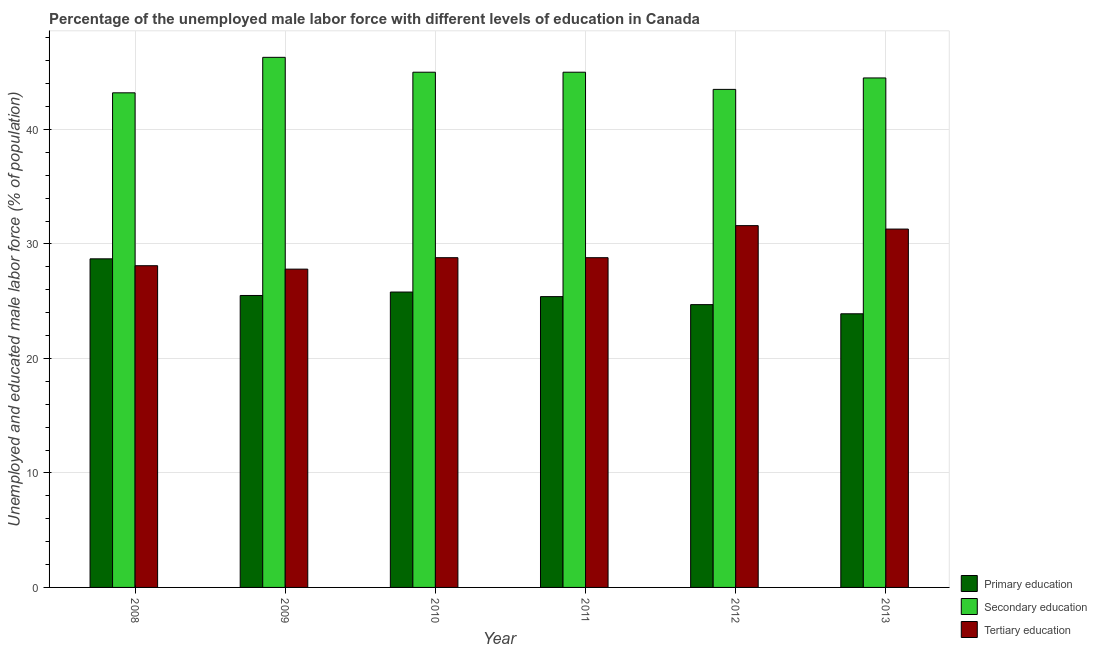Are the number of bars on each tick of the X-axis equal?
Make the answer very short. Yes. How many bars are there on the 3rd tick from the right?
Make the answer very short. 3. In how many cases, is the number of bars for a given year not equal to the number of legend labels?
Offer a very short reply. 0. What is the percentage of male labor force who received secondary education in 2008?
Ensure brevity in your answer.  43.2. Across all years, what is the maximum percentage of male labor force who received tertiary education?
Your answer should be very brief. 31.6. Across all years, what is the minimum percentage of male labor force who received tertiary education?
Offer a terse response. 27.8. In which year was the percentage of male labor force who received primary education maximum?
Your answer should be very brief. 2008. In which year was the percentage of male labor force who received secondary education minimum?
Keep it short and to the point. 2008. What is the total percentage of male labor force who received primary education in the graph?
Your answer should be very brief. 154. What is the difference between the percentage of male labor force who received primary education in 2013 and the percentage of male labor force who received tertiary education in 2012?
Offer a terse response. -0.8. What is the average percentage of male labor force who received secondary education per year?
Your response must be concise. 44.58. In the year 2008, what is the difference between the percentage of male labor force who received tertiary education and percentage of male labor force who received secondary education?
Your answer should be compact. 0. In how many years, is the percentage of male labor force who received secondary education greater than 34 %?
Make the answer very short. 6. What is the ratio of the percentage of male labor force who received tertiary education in 2011 to that in 2013?
Offer a terse response. 0.92. Is the percentage of male labor force who received primary education in 2008 less than that in 2012?
Offer a terse response. No. What is the difference between the highest and the second highest percentage of male labor force who received tertiary education?
Keep it short and to the point. 0.3. What is the difference between the highest and the lowest percentage of male labor force who received primary education?
Make the answer very short. 4.8. What does the 2nd bar from the left in 2013 represents?
Give a very brief answer. Secondary education. What does the 2nd bar from the right in 2008 represents?
Your response must be concise. Secondary education. Is it the case that in every year, the sum of the percentage of male labor force who received primary education and percentage of male labor force who received secondary education is greater than the percentage of male labor force who received tertiary education?
Make the answer very short. Yes. How many bars are there?
Ensure brevity in your answer.  18. Are all the bars in the graph horizontal?
Your answer should be compact. No. How many years are there in the graph?
Make the answer very short. 6. Are the values on the major ticks of Y-axis written in scientific E-notation?
Provide a succinct answer. No. Does the graph contain any zero values?
Ensure brevity in your answer.  No. Where does the legend appear in the graph?
Your answer should be compact. Bottom right. How many legend labels are there?
Your response must be concise. 3. What is the title of the graph?
Offer a very short reply. Percentage of the unemployed male labor force with different levels of education in Canada. Does "Tertiary" appear as one of the legend labels in the graph?
Your response must be concise. No. What is the label or title of the Y-axis?
Provide a succinct answer. Unemployed and educated male labor force (% of population). What is the Unemployed and educated male labor force (% of population) in Primary education in 2008?
Your answer should be compact. 28.7. What is the Unemployed and educated male labor force (% of population) in Secondary education in 2008?
Your answer should be compact. 43.2. What is the Unemployed and educated male labor force (% of population) in Tertiary education in 2008?
Provide a succinct answer. 28.1. What is the Unemployed and educated male labor force (% of population) of Secondary education in 2009?
Give a very brief answer. 46.3. What is the Unemployed and educated male labor force (% of population) in Tertiary education in 2009?
Make the answer very short. 27.8. What is the Unemployed and educated male labor force (% of population) of Primary education in 2010?
Your response must be concise. 25.8. What is the Unemployed and educated male labor force (% of population) of Secondary education in 2010?
Offer a very short reply. 45. What is the Unemployed and educated male labor force (% of population) of Tertiary education in 2010?
Your answer should be very brief. 28.8. What is the Unemployed and educated male labor force (% of population) of Primary education in 2011?
Your answer should be very brief. 25.4. What is the Unemployed and educated male labor force (% of population) in Tertiary education in 2011?
Make the answer very short. 28.8. What is the Unemployed and educated male labor force (% of population) of Primary education in 2012?
Offer a terse response. 24.7. What is the Unemployed and educated male labor force (% of population) of Secondary education in 2012?
Keep it short and to the point. 43.5. What is the Unemployed and educated male labor force (% of population) of Tertiary education in 2012?
Your response must be concise. 31.6. What is the Unemployed and educated male labor force (% of population) of Primary education in 2013?
Keep it short and to the point. 23.9. What is the Unemployed and educated male labor force (% of population) in Secondary education in 2013?
Offer a very short reply. 44.5. What is the Unemployed and educated male labor force (% of population) of Tertiary education in 2013?
Provide a succinct answer. 31.3. Across all years, what is the maximum Unemployed and educated male labor force (% of population) in Primary education?
Give a very brief answer. 28.7. Across all years, what is the maximum Unemployed and educated male labor force (% of population) in Secondary education?
Keep it short and to the point. 46.3. Across all years, what is the maximum Unemployed and educated male labor force (% of population) in Tertiary education?
Ensure brevity in your answer.  31.6. Across all years, what is the minimum Unemployed and educated male labor force (% of population) of Primary education?
Give a very brief answer. 23.9. Across all years, what is the minimum Unemployed and educated male labor force (% of population) of Secondary education?
Make the answer very short. 43.2. Across all years, what is the minimum Unemployed and educated male labor force (% of population) in Tertiary education?
Provide a succinct answer. 27.8. What is the total Unemployed and educated male labor force (% of population) of Primary education in the graph?
Ensure brevity in your answer.  154. What is the total Unemployed and educated male labor force (% of population) of Secondary education in the graph?
Provide a short and direct response. 267.5. What is the total Unemployed and educated male labor force (% of population) in Tertiary education in the graph?
Keep it short and to the point. 176.4. What is the difference between the Unemployed and educated male labor force (% of population) in Primary education in 2008 and that in 2009?
Provide a short and direct response. 3.2. What is the difference between the Unemployed and educated male labor force (% of population) in Secondary education in 2008 and that in 2009?
Your response must be concise. -3.1. What is the difference between the Unemployed and educated male labor force (% of population) of Tertiary education in 2008 and that in 2009?
Offer a very short reply. 0.3. What is the difference between the Unemployed and educated male labor force (% of population) in Tertiary education in 2008 and that in 2010?
Keep it short and to the point. -0.7. What is the difference between the Unemployed and educated male labor force (% of population) in Primary education in 2008 and that in 2011?
Your response must be concise. 3.3. What is the difference between the Unemployed and educated male labor force (% of population) of Secondary education in 2008 and that in 2012?
Make the answer very short. -0.3. What is the difference between the Unemployed and educated male labor force (% of population) of Primary education in 2008 and that in 2013?
Offer a terse response. 4.8. What is the difference between the Unemployed and educated male labor force (% of population) in Primary education in 2009 and that in 2010?
Keep it short and to the point. -0.3. What is the difference between the Unemployed and educated male labor force (% of population) in Secondary education in 2009 and that in 2010?
Offer a terse response. 1.3. What is the difference between the Unemployed and educated male labor force (% of population) in Tertiary education in 2009 and that in 2010?
Provide a succinct answer. -1. What is the difference between the Unemployed and educated male labor force (% of population) in Tertiary education in 2009 and that in 2011?
Give a very brief answer. -1. What is the difference between the Unemployed and educated male labor force (% of population) in Primary education in 2009 and that in 2012?
Provide a succinct answer. 0.8. What is the difference between the Unemployed and educated male labor force (% of population) of Secondary education in 2009 and that in 2013?
Provide a short and direct response. 1.8. What is the difference between the Unemployed and educated male labor force (% of population) in Tertiary education in 2009 and that in 2013?
Provide a short and direct response. -3.5. What is the difference between the Unemployed and educated male labor force (% of population) of Tertiary education in 2010 and that in 2011?
Give a very brief answer. 0. What is the difference between the Unemployed and educated male labor force (% of population) of Primary education in 2010 and that in 2012?
Offer a very short reply. 1.1. What is the difference between the Unemployed and educated male labor force (% of population) in Secondary education in 2010 and that in 2012?
Make the answer very short. 1.5. What is the difference between the Unemployed and educated male labor force (% of population) of Secondary education in 2010 and that in 2013?
Give a very brief answer. 0.5. What is the difference between the Unemployed and educated male labor force (% of population) of Tertiary education in 2010 and that in 2013?
Give a very brief answer. -2.5. What is the difference between the Unemployed and educated male labor force (% of population) in Primary education in 2011 and that in 2012?
Offer a terse response. 0.7. What is the difference between the Unemployed and educated male labor force (% of population) of Secondary education in 2011 and that in 2012?
Provide a short and direct response. 1.5. What is the difference between the Unemployed and educated male labor force (% of population) of Tertiary education in 2011 and that in 2012?
Make the answer very short. -2.8. What is the difference between the Unemployed and educated male labor force (% of population) of Secondary education in 2011 and that in 2013?
Keep it short and to the point. 0.5. What is the difference between the Unemployed and educated male labor force (% of population) in Secondary education in 2012 and that in 2013?
Ensure brevity in your answer.  -1. What is the difference between the Unemployed and educated male labor force (% of population) of Primary education in 2008 and the Unemployed and educated male labor force (% of population) of Secondary education in 2009?
Make the answer very short. -17.6. What is the difference between the Unemployed and educated male labor force (% of population) in Secondary education in 2008 and the Unemployed and educated male labor force (% of population) in Tertiary education in 2009?
Ensure brevity in your answer.  15.4. What is the difference between the Unemployed and educated male labor force (% of population) in Primary education in 2008 and the Unemployed and educated male labor force (% of population) in Secondary education in 2010?
Your response must be concise. -16.3. What is the difference between the Unemployed and educated male labor force (% of population) of Primary education in 2008 and the Unemployed and educated male labor force (% of population) of Tertiary education in 2010?
Make the answer very short. -0.1. What is the difference between the Unemployed and educated male labor force (% of population) in Primary education in 2008 and the Unemployed and educated male labor force (% of population) in Secondary education in 2011?
Keep it short and to the point. -16.3. What is the difference between the Unemployed and educated male labor force (% of population) of Primary education in 2008 and the Unemployed and educated male labor force (% of population) of Tertiary education in 2011?
Ensure brevity in your answer.  -0.1. What is the difference between the Unemployed and educated male labor force (% of population) of Secondary education in 2008 and the Unemployed and educated male labor force (% of population) of Tertiary education in 2011?
Ensure brevity in your answer.  14.4. What is the difference between the Unemployed and educated male labor force (% of population) in Primary education in 2008 and the Unemployed and educated male labor force (% of population) in Secondary education in 2012?
Your answer should be compact. -14.8. What is the difference between the Unemployed and educated male labor force (% of population) in Primary education in 2008 and the Unemployed and educated male labor force (% of population) in Secondary education in 2013?
Ensure brevity in your answer.  -15.8. What is the difference between the Unemployed and educated male labor force (% of population) of Primary education in 2008 and the Unemployed and educated male labor force (% of population) of Tertiary education in 2013?
Your answer should be compact. -2.6. What is the difference between the Unemployed and educated male labor force (% of population) in Secondary education in 2008 and the Unemployed and educated male labor force (% of population) in Tertiary education in 2013?
Your answer should be very brief. 11.9. What is the difference between the Unemployed and educated male labor force (% of population) of Primary education in 2009 and the Unemployed and educated male labor force (% of population) of Secondary education in 2010?
Offer a very short reply. -19.5. What is the difference between the Unemployed and educated male labor force (% of population) of Primary education in 2009 and the Unemployed and educated male labor force (% of population) of Tertiary education in 2010?
Your answer should be very brief. -3.3. What is the difference between the Unemployed and educated male labor force (% of population) in Secondary education in 2009 and the Unemployed and educated male labor force (% of population) in Tertiary education in 2010?
Your answer should be compact. 17.5. What is the difference between the Unemployed and educated male labor force (% of population) in Primary education in 2009 and the Unemployed and educated male labor force (% of population) in Secondary education in 2011?
Your answer should be compact. -19.5. What is the difference between the Unemployed and educated male labor force (% of population) in Primary education in 2009 and the Unemployed and educated male labor force (% of population) in Tertiary education in 2012?
Provide a succinct answer. -6.1. What is the difference between the Unemployed and educated male labor force (% of population) of Secondary education in 2009 and the Unemployed and educated male labor force (% of population) of Tertiary education in 2012?
Give a very brief answer. 14.7. What is the difference between the Unemployed and educated male labor force (% of population) in Primary education in 2009 and the Unemployed and educated male labor force (% of population) in Secondary education in 2013?
Provide a short and direct response. -19. What is the difference between the Unemployed and educated male labor force (% of population) in Primary education in 2010 and the Unemployed and educated male labor force (% of population) in Secondary education in 2011?
Provide a short and direct response. -19.2. What is the difference between the Unemployed and educated male labor force (% of population) in Secondary education in 2010 and the Unemployed and educated male labor force (% of population) in Tertiary education in 2011?
Your answer should be very brief. 16.2. What is the difference between the Unemployed and educated male labor force (% of population) in Primary education in 2010 and the Unemployed and educated male labor force (% of population) in Secondary education in 2012?
Make the answer very short. -17.7. What is the difference between the Unemployed and educated male labor force (% of population) in Primary education in 2010 and the Unemployed and educated male labor force (% of population) in Tertiary education in 2012?
Offer a very short reply. -5.8. What is the difference between the Unemployed and educated male labor force (% of population) in Secondary education in 2010 and the Unemployed and educated male labor force (% of population) in Tertiary education in 2012?
Your answer should be compact. 13.4. What is the difference between the Unemployed and educated male labor force (% of population) of Primary education in 2010 and the Unemployed and educated male labor force (% of population) of Secondary education in 2013?
Your answer should be compact. -18.7. What is the difference between the Unemployed and educated male labor force (% of population) in Secondary education in 2010 and the Unemployed and educated male labor force (% of population) in Tertiary education in 2013?
Give a very brief answer. 13.7. What is the difference between the Unemployed and educated male labor force (% of population) of Primary education in 2011 and the Unemployed and educated male labor force (% of population) of Secondary education in 2012?
Provide a succinct answer. -18.1. What is the difference between the Unemployed and educated male labor force (% of population) of Primary education in 2011 and the Unemployed and educated male labor force (% of population) of Secondary education in 2013?
Offer a terse response. -19.1. What is the difference between the Unemployed and educated male labor force (% of population) of Primary education in 2012 and the Unemployed and educated male labor force (% of population) of Secondary education in 2013?
Your answer should be very brief. -19.8. What is the average Unemployed and educated male labor force (% of population) of Primary education per year?
Your response must be concise. 25.67. What is the average Unemployed and educated male labor force (% of population) of Secondary education per year?
Provide a short and direct response. 44.58. What is the average Unemployed and educated male labor force (% of population) in Tertiary education per year?
Make the answer very short. 29.4. In the year 2008, what is the difference between the Unemployed and educated male labor force (% of population) in Primary education and Unemployed and educated male labor force (% of population) in Tertiary education?
Provide a succinct answer. 0.6. In the year 2009, what is the difference between the Unemployed and educated male labor force (% of population) in Primary education and Unemployed and educated male labor force (% of population) in Secondary education?
Your response must be concise. -20.8. In the year 2009, what is the difference between the Unemployed and educated male labor force (% of population) of Secondary education and Unemployed and educated male labor force (% of population) of Tertiary education?
Ensure brevity in your answer.  18.5. In the year 2010, what is the difference between the Unemployed and educated male labor force (% of population) of Primary education and Unemployed and educated male labor force (% of population) of Secondary education?
Make the answer very short. -19.2. In the year 2011, what is the difference between the Unemployed and educated male labor force (% of population) in Primary education and Unemployed and educated male labor force (% of population) in Secondary education?
Provide a succinct answer. -19.6. In the year 2011, what is the difference between the Unemployed and educated male labor force (% of population) of Secondary education and Unemployed and educated male labor force (% of population) of Tertiary education?
Your response must be concise. 16.2. In the year 2012, what is the difference between the Unemployed and educated male labor force (% of population) in Primary education and Unemployed and educated male labor force (% of population) in Secondary education?
Provide a short and direct response. -18.8. In the year 2012, what is the difference between the Unemployed and educated male labor force (% of population) of Primary education and Unemployed and educated male labor force (% of population) of Tertiary education?
Ensure brevity in your answer.  -6.9. In the year 2013, what is the difference between the Unemployed and educated male labor force (% of population) in Primary education and Unemployed and educated male labor force (% of population) in Secondary education?
Your answer should be compact. -20.6. In the year 2013, what is the difference between the Unemployed and educated male labor force (% of population) of Primary education and Unemployed and educated male labor force (% of population) of Tertiary education?
Provide a short and direct response. -7.4. In the year 2013, what is the difference between the Unemployed and educated male labor force (% of population) in Secondary education and Unemployed and educated male labor force (% of population) in Tertiary education?
Offer a very short reply. 13.2. What is the ratio of the Unemployed and educated male labor force (% of population) of Primary education in 2008 to that in 2009?
Provide a short and direct response. 1.13. What is the ratio of the Unemployed and educated male labor force (% of population) in Secondary education in 2008 to that in 2009?
Make the answer very short. 0.93. What is the ratio of the Unemployed and educated male labor force (% of population) in Tertiary education in 2008 to that in 2009?
Your answer should be compact. 1.01. What is the ratio of the Unemployed and educated male labor force (% of population) of Primary education in 2008 to that in 2010?
Ensure brevity in your answer.  1.11. What is the ratio of the Unemployed and educated male labor force (% of population) in Secondary education in 2008 to that in 2010?
Keep it short and to the point. 0.96. What is the ratio of the Unemployed and educated male labor force (% of population) of Tertiary education in 2008 to that in 2010?
Keep it short and to the point. 0.98. What is the ratio of the Unemployed and educated male labor force (% of population) in Primary education in 2008 to that in 2011?
Provide a short and direct response. 1.13. What is the ratio of the Unemployed and educated male labor force (% of population) of Tertiary education in 2008 to that in 2011?
Provide a succinct answer. 0.98. What is the ratio of the Unemployed and educated male labor force (% of population) in Primary education in 2008 to that in 2012?
Offer a very short reply. 1.16. What is the ratio of the Unemployed and educated male labor force (% of population) of Tertiary education in 2008 to that in 2012?
Give a very brief answer. 0.89. What is the ratio of the Unemployed and educated male labor force (% of population) of Primary education in 2008 to that in 2013?
Offer a very short reply. 1.2. What is the ratio of the Unemployed and educated male labor force (% of population) of Secondary education in 2008 to that in 2013?
Provide a succinct answer. 0.97. What is the ratio of the Unemployed and educated male labor force (% of population) in Tertiary education in 2008 to that in 2013?
Provide a succinct answer. 0.9. What is the ratio of the Unemployed and educated male labor force (% of population) of Primary education in 2009 to that in 2010?
Your answer should be very brief. 0.99. What is the ratio of the Unemployed and educated male labor force (% of population) of Secondary education in 2009 to that in 2010?
Provide a short and direct response. 1.03. What is the ratio of the Unemployed and educated male labor force (% of population) of Tertiary education in 2009 to that in 2010?
Keep it short and to the point. 0.97. What is the ratio of the Unemployed and educated male labor force (% of population) of Primary education in 2009 to that in 2011?
Your answer should be compact. 1. What is the ratio of the Unemployed and educated male labor force (% of population) in Secondary education in 2009 to that in 2011?
Your answer should be very brief. 1.03. What is the ratio of the Unemployed and educated male labor force (% of population) of Tertiary education in 2009 to that in 2011?
Provide a short and direct response. 0.97. What is the ratio of the Unemployed and educated male labor force (% of population) in Primary education in 2009 to that in 2012?
Offer a very short reply. 1.03. What is the ratio of the Unemployed and educated male labor force (% of population) in Secondary education in 2009 to that in 2012?
Make the answer very short. 1.06. What is the ratio of the Unemployed and educated male labor force (% of population) in Tertiary education in 2009 to that in 2012?
Provide a succinct answer. 0.88. What is the ratio of the Unemployed and educated male labor force (% of population) in Primary education in 2009 to that in 2013?
Provide a succinct answer. 1.07. What is the ratio of the Unemployed and educated male labor force (% of population) of Secondary education in 2009 to that in 2013?
Provide a succinct answer. 1.04. What is the ratio of the Unemployed and educated male labor force (% of population) of Tertiary education in 2009 to that in 2013?
Offer a very short reply. 0.89. What is the ratio of the Unemployed and educated male labor force (% of population) of Primary education in 2010 to that in 2011?
Your response must be concise. 1.02. What is the ratio of the Unemployed and educated male labor force (% of population) of Secondary education in 2010 to that in 2011?
Offer a terse response. 1. What is the ratio of the Unemployed and educated male labor force (% of population) in Tertiary education in 2010 to that in 2011?
Provide a short and direct response. 1. What is the ratio of the Unemployed and educated male labor force (% of population) in Primary education in 2010 to that in 2012?
Offer a very short reply. 1.04. What is the ratio of the Unemployed and educated male labor force (% of population) in Secondary education in 2010 to that in 2012?
Your response must be concise. 1.03. What is the ratio of the Unemployed and educated male labor force (% of population) in Tertiary education in 2010 to that in 2012?
Provide a succinct answer. 0.91. What is the ratio of the Unemployed and educated male labor force (% of population) of Primary education in 2010 to that in 2013?
Provide a succinct answer. 1.08. What is the ratio of the Unemployed and educated male labor force (% of population) in Secondary education in 2010 to that in 2013?
Provide a short and direct response. 1.01. What is the ratio of the Unemployed and educated male labor force (% of population) of Tertiary education in 2010 to that in 2013?
Provide a short and direct response. 0.92. What is the ratio of the Unemployed and educated male labor force (% of population) in Primary education in 2011 to that in 2012?
Keep it short and to the point. 1.03. What is the ratio of the Unemployed and educated male labor force (% of population) in Secondary education in 2011 to that in 2012?
Keep it short and to the point. 1.03. What is the ratio of the Unemployed and educated male labor force (% of population) in Tertiary education in 2011 to that in 2012?
Provide a succinct answer. 0.91. What is the ratio of the Unemployed and educated male labor force (% of population) in Primary education in 2011 to that in 2013?
Provide a succinct answer. 1.06. What is the ratio of the Unemployed and educated male labor force (% of population) of Secondary education in 2011 to that in 2013?
Offer a terse response. 1.01. What is the ratio of the Unemployed and educated male labor force (% of population) of Tertiary education in 2011 to that in 2013?
Offer a terse response. 0.92. What is the ratio of the Unemployed and educated male labor force (% of population) of Primary education in 2012 to that in 2013?
Your answer should be very brief. 1.03. What is the ratio of the Unemployed and educated male labor force (% of population) in Secondary education in 2012 to that in 2013?
Offer a terse response. 0.98. What is the ratio of the Unemployed and educated male labor force (% of population) of Tertiary education in 2012 to that in 2013?
Offer a terse response. 1.01. 